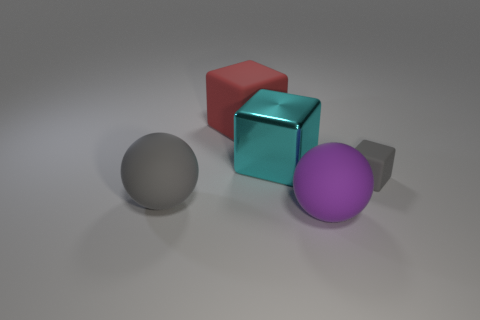There is a gray object that is the same size as the purple matte ball; what material is it?
Provide a short and direct response. Rubber. Do the large matte thing that is behind the large shiny block and the tiny rubber thing have the same shape?
Make the answer very short. Yes. Does the tiny rubber object have the same color as the large metallic block?
Keep it short and to the point. No. What number of things are cyan metallic blocks behind the big gray rubber thing or big purple cylinders?
Make the answer very short. 1. The red matte thing that is the same size as the gray ball is what shape?
Give a very brief answer. Cube. Do the ball right of the big red cube and the gray rubber object on the right side of the red rubber cube have the same size?
Provide a short and direct response. No. The small block that is the same material as the big gray thing is what color?
Make the answer very short. Gray. Are the tiny object in front of the big red block and the gray object in front of the gray block made of the same material?
Make the answer very short. Yes. Are there any metal objects of the same size as the purple rubber object?
Your answer should be compact. Yes. There is a gray matte thing that is to the left of the sphere that is to the right of the big gray matte ball; what is its size?
Keep it short and to the point. Large. 